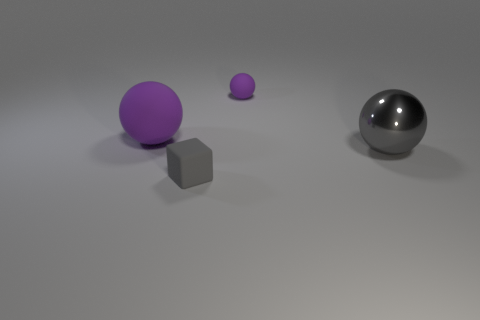Does the ball on the left side of the rubber block have the same size as the cube left of the tiny purple rubber object?
Make the answer very short. No. There is a purple rubber sphere that is to the right of the big rubber thing to the left of the tiny purple rubber thing; what size is it?
Your answer should be very brief. Small. There is a sphere that is both to the right of the tiny gray cube and in front of the tiny rubber sphere; what material is it?
Your response must be concise. Metal. The small sphere is what color?
Provide a succinct answer. Purple. Is there anything else that is the same material as the large gray ball?
Your answer should be very brief. No. There is a big thing on the right side of the tiny rubber sphere; what shape is it?
Make the answer very short. Sphere. Are there any gray objects behind the sphere that is to the left of the gray object that is to the left of the big gray metal sphere?
Your response must be concise. No. Is there anything else that is the same shape as the small gray thing?
Provide a short and direct response. No. Is there a gray metallic object?
Offer a very short reply. Yes. Are the small object in front of the large rubber thing and the big thing to the right of the tiny gray rubber thing made of the same material?
Offer a terse response. No. 